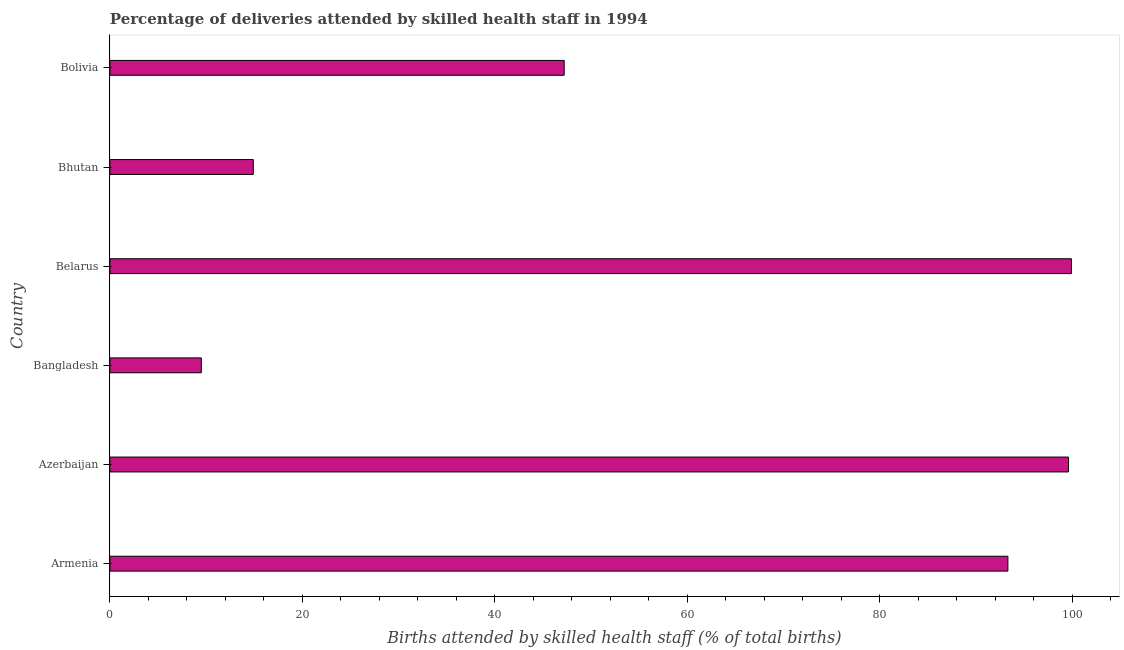What is the title of the graph?
Offer a very short reply. Percentage of deliveries attended by skilled health staff in 1994. What is the label or title of the X-axis?
Make the answer very short. Births attended by skilled health staff (% of total births). What is the label or title of the Y-axis?
Offer a terse response. Country. What is the number of births attended by skilled health staff in Azerbaijan?
Give a very brief answer. 99.6. Across all countries, what is the maximum number of births attended by skilled health staff?
Provide a short and direct response. 99.9. In which country was the number of births attended by skilled health staff maximum?
Offer a very short reply. Belarus. What is the sum of the number of births attended by skilled health staff?
Offer a very short reply. 364.4. What is the average number of births attended by skilled health staff per country?
Offer a terse response. 60.73. What is the median number of births attended by skilled health staff?
Offer a terse response. 70.25. What is the ratio of the number of births attended by skilled health staff in Bangladesh to that in Bhutan?
Offer a terse response. 0.64. Is the difference between the number of births attended by skilled health staff in Bangladesh and Bhutan greater than the difference between any two countries?
Provide a succinct answer. No. What is the difference between the highest and the lowest number of births attended by skilled health staff?
Give a very brief answer. 90.4. Are all the bars in the graph horizontal?
Your answer should be very brief. Yes. How many countries are there in the graph?
Give a very brief answer. 6. What is the difference between two consecutive major ticks on the X-axis?
Offer a very short reply. 20. What is the Births attended by skilled health staff (% of total births) in Armenia?
Ensure brevity in your answer.  93.3. What is the Births attended by skilled health staff (% of total births) in Azerbaijan?
Your response must be concise. 99.6. What is the Births attended by skilled health staff (% of total births) in Bangladesh?
Offer a very short reply. 9.5. What is the Births attended by skilled health staff (% of total births) of Belarus?
Your response must be concise. 99.9. What is the Births attended by skilled health staff (% of total births) in Bolivia?
Your answer should be compact. 47.2. What is the difference between the Births attended by skilled health staff (% of total births) in Armenia and Azerbaijan?
Give a very brief answer. -6.3. What is the difference between the Births attended by skilled health staff (% of total births) in Armenia and Bangladesh?
Offer a very short reply. 83.8. What is the difference between the Births attended by skilled health staff (% of total births) in Armenia and Bhutan?
Your response must be concise. 78.4. What is the difference between the Births attended by skilled health staff (% of total births) in Armenia and Bolivia?
Make the answer very short. 46.1. What is the difference between the Births attended by skilled health staff (% of total births) in Azerbaijan and Bangladesh?
Your response must be concise. 90.1. What is the difference between the Births attended by skilled health staff (% of total births) in Azerbaijan and Belarus?
Offer a very short reply. -0.3. What is the difference between the Births attended by skilled health staff (% of total births) in Azerbaijan and Bhutan?
Ensure brevity in your answer.  84.7. What is the difference between the Births attended by skilled health staff (% of total births) in Azerbaijan and Bolivia?
Ensure brevity in your answer.  52.4. What is the difference between the Births attended by skilled health staff (% of total births) in Bangladesh and Belarus?
Make the answer very short. -90.4. What is the difference between the Births attended by skilled health staff (% of total births) in Bangladesh and Bolivia?
Provide a short and direct response. -37.7. What is the difference between the Births attended by skilled health staff (% of total births) in Belarus and Bolivia?
Provide a short and direct response. 52.7. What is the difference between the Births attended by skilled health staff (% of total births) in Bhutan and Bolivia?
Give a very brief answer. -32.3. What is the ratio of the Births attended by skilled health staff (% of total births) in Armenia to that in Azerbaijan?
Your response must be concise. 0.94. What is the ratio of the Births attended by skilled health staff (% of total births) in Armenia to that in Bangladesh?
Offer a terse response. 9.82. What is the ratio of the Births attended by skilled health staff (% of total births) in Armenia to that in Belarus?
Your response must be concise. 0.93. What is the ratio of the Births attended by skilled health staff (% of total births) in Armenia to that in Bhutan?
Your answer should be very brief. 6.26. What is the ratio of the Births attended by skilled health staff (% of total births) in Armenia to that in Bolivia?
Your answer should be compact. 1.98. What is the ratio of the Births attended by skilled health staff (% of total births) in Azerbaijan to that in Bangladesh?
Provide a short and direct response. 10.48. What is the ratio of the Births attended by skilled health staff (% of total births) in Azerbaijan to that in Belarus?
Offer a very short reply. 1. What is the ratio of the Births attended by skilled health staff (% of total births) in Azerbaijan to that in Bhutan?
Your answer should be very brief. 6.68. What is the ratio of the Births attended by skilled health staff (% of total births) in Azerbaijan to that in Bolivia?
Make the answer very short. 2.11. What is the ratio of the Births attended by skilled health staff (% of total births) in Bangladesh to that in Belarus?
Your answer should be compact. 0.1. What is the ratio of the Births attended by skilled health staff (% of total births) in Bangladesh to that in Bhutan?
Offer a very short reply. 0.64. What is the ratio of the Births attended by skilled health staff (% of total births) in Bangladesh to that in Bolivia?
Make the answer very short. 0.2. What is the ratio of the Births attended by skilled health staff (% of total births) in Belarus to that in Bhutan?
Provide a succinct answer. 6.71. What is the ratio of the Births attended by skilled health staff (% of total births) in Belarus to that in Bolivia?
Make the answer very short. 2.12. What is the ratio of the Births attended by skilled health staff (% of total births) in Bhutan to that in Bolivia?
Your answer should be very brief. 0.32. 